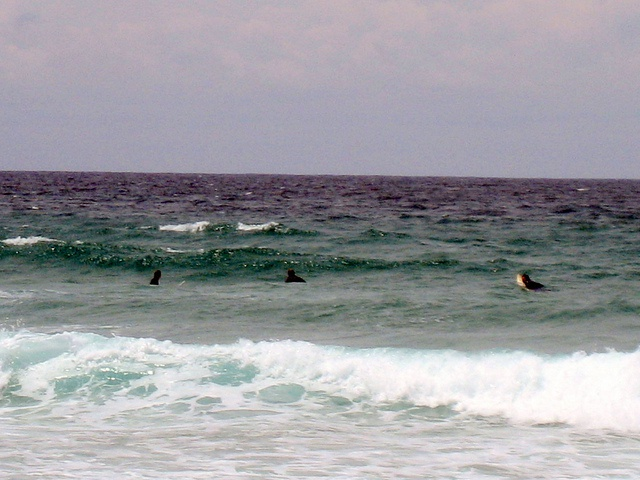Describe the objects in this image and their specific colors. I can see people in darkgray, black, maroon, and purple tones, people in darkgray, black, gray, and maroon tones, people in darkgray, black, gray, and maroon tones, and surfboard in darkgray and tan tones in this image. 